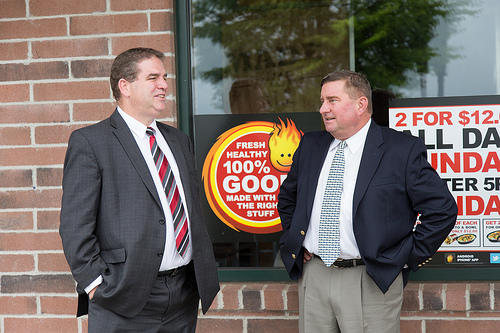<image>
Is there a bricks to the left of the window? Yes. From this viewpoint, the bricks is positioned to the left side relative to the window. 